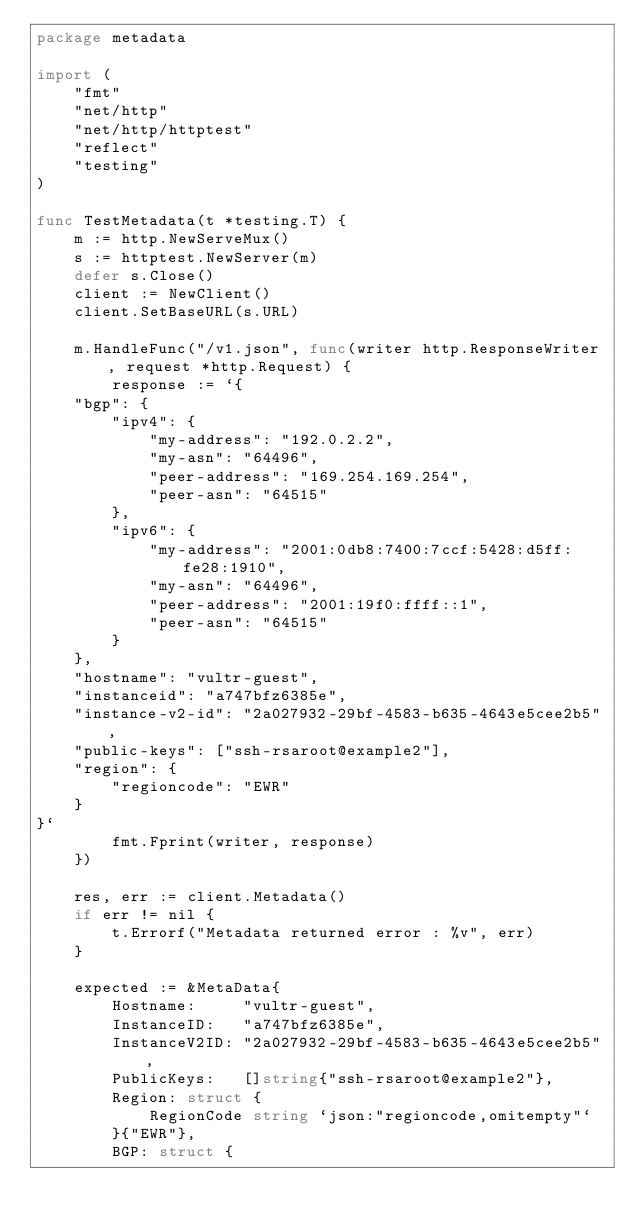<code> <loc_0><loc_0><loc_500><loc_500><_Go_>package metadata

import (
	"fmt"
	"net/http"
	"net/http/httptest"
	"reflect"
	"testing"
)

func TestMetadata(t *testing.T) {
	m := http.NewServeMux()
	s := httptest.NewServer(m)
	defer s.Close()
	client := NewClient()
	client.SetBaseURL(s.URL)

	m.HandleFunc("/v1.json", func(writer http.ResponseWriter, request *http.Request) {
		response := `{
    "bgp": {
        "ipv4": {
            "my-address": "192.0.2.2",
            "my-asn": "64496",
            "peer-address": "169.254.169.254",
            "peer-asn": "64515"
        },
        "ipv6": {
            "my-address": "2001:0db8:7400:7ccf:5428:d5ff:fe28:1910",
            "my-asn": "64496",
            "peer-address": "2001:19f0:ffff::1",
            "peer-asn": "64515"
        }
    },
    "hostname": "vultr-guest",
    "instanceid": "a747bfz6385e",
	"instance-v2-id": "2a027932-29bf-4583-b635-4643e5cee2b5",
    "public-keys": ["ssh-rsaroot@example2"],
    "region": {
        "regioncode": "EWR"
    }
}`
		fmt.Fprint(writer, response)
	})

	res, err := client.Metadata()
	if err != nil {
		t.Errorf("Metadata returned error : %v", err)
	}

	expected := &MetaData{
		Hostname:     "vultr-guest",
		InstanceID:   "a747bfz6385e",
		InstanceV2ID: "2a027932-29bf-4583-b635-4643e5cee2b5",
		PublicKeys:   []string{"ssh-rsaroot@example2"},
		Region: struct {
			RegionCode string `json:"regioncode,omitempty"`
		}{"EWR"},
		BGP: struct {</code> 